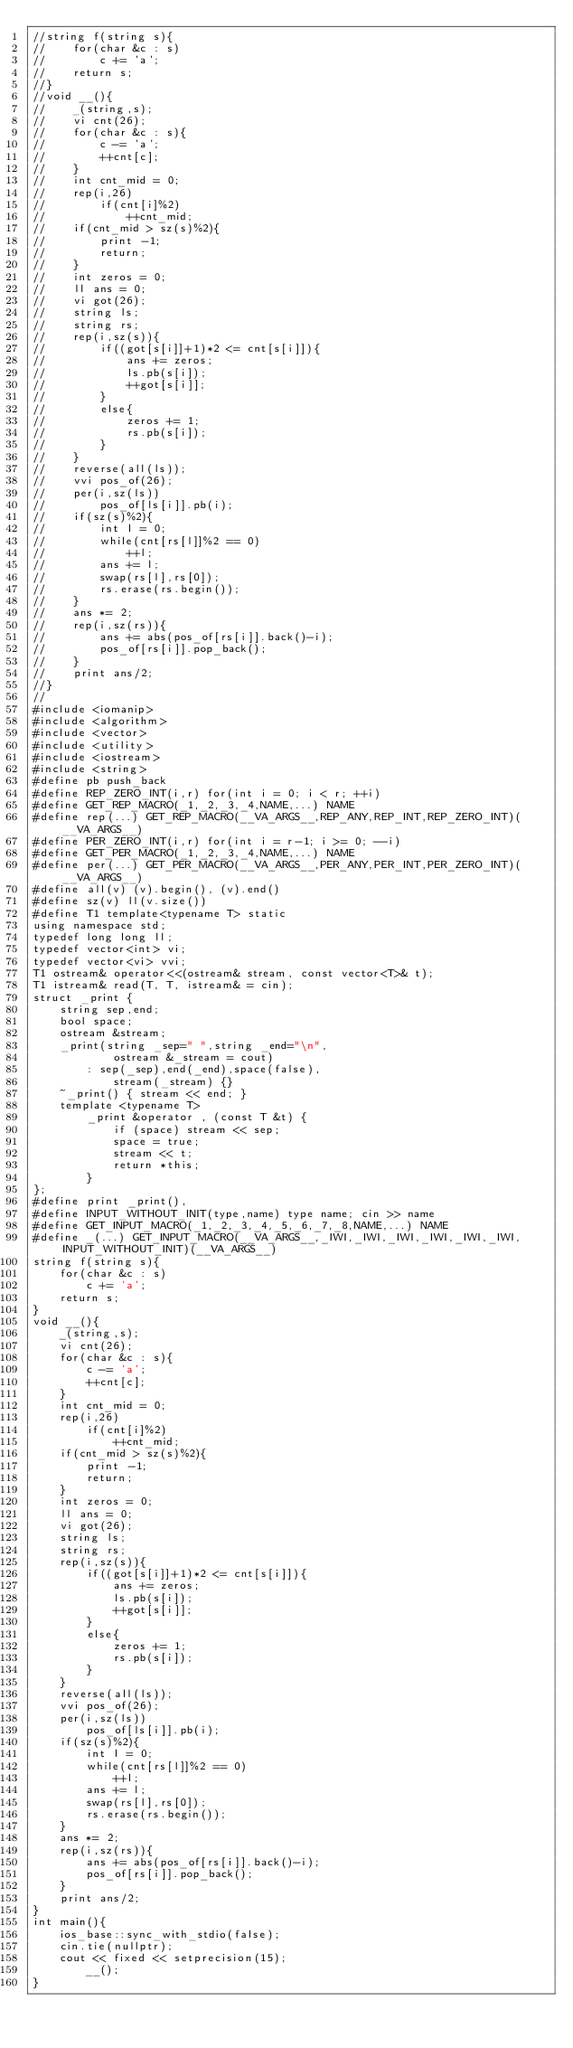<code> <loc_0><loc_0><loc_500><loc_500><_C++_>//string f(string s){
//    for(char &c : s)
//        c += 'a';
//    return s;
//}
//void __(){
//    _(string,s);
//    vi cnt(26);
//    for(char &c : s){
//        c -= 'a';
//        ++cnt[c];
//    }
//    int cnt_mid = 0;
//    rep(i,26)
//        if(cnt[i]%2)
//            ++cnt_mid;
//    if(cnt_mid > sz(s)%2){
//        print -1;
//        return;
//    }
//    int zeros = 0;
//    ll ans = 0;
//    vi got(26);
//    string ls;
//    string rs;
//    rep(i,sz(s)){
//        if((got[s[i]]+1)*2 <= cnt[s[i]]){
//            ans += zeros;
//            ls.pb(s[i]);
//            ++got[s[i]];
//        }
//        else{
//            zeros += 1;
//            rs.pb(s[i]);
//        }
//    }
//    reverse(all(ls));
//    vvi pos_of(26);
//    per(i,sz(ls))
//        pos_of[ls[i]].pb(i);
//    if(sz(s)%2){
//        int l = 0;
//        while(cnt[rs[l]]%2 == 0)
//            ++l;
//        ans += l;
//        swap(rs[l],rs[0]);
//        rs.erase(rs.begin());
//    }
//    ans *= 2;
//    rep(i,sz(rs)){
//        ans += abs(pos_of[rs[i]].back()-i);
//        pos_of[rs[i]].pop_back();
//    }
//    print ans/2;
//}
//
#include <iomanip>
#include <algorithm>
#include <vector>
#include <utility>
#include <iostream>
#include <string>
#define pb push_back
#define REP_ZERO_INT(i,r) for(int i = 0; i < r; ++i)
#define GET_REP_MACRO(_1,_2,_3,_4,NAME,...) NAME
#define rep(...) GET_REP_MACRO(__VA_ARGS__,REP_ANY,REP_INT,REP_ZERO_INT)(__VA_ARGS__)
#define PER_ZERO_INT(i,r) for(int i = r-1; i >= 0; --i)
#define GET_PER_MACRO(_1,_2,_3,_4,NAME,...) NAME
#define per(...) GET_PER_MACRO(__VA_ARGS__,PER_ANY,PER_INT,PER_ZERO_INT)(__VA_ARGS__)
#define all(v) (v).begin(), (v).end()
#define sz(v) ll(v.size())
#define T1 template<typename T> static
using namespace std;
typedef long long ll;
typedef vector<int> vi;
typedef vector<vi> vvi;
T1 ostream& operator<<(ostream& stream, const vector<T>& t);
T1 istream& read(T, T, istream& = cin);
struct _print {
    string sep,end;
    bool space;
    ostream &stream;
    _print(string _sep=" ",string _end="\n",
            ostream &_stream = cout)
        : sep(_sep),end(_end),space(false),
            stream(_stream) {}
    ~_print() { stream << end; }
    template <typename T>
        _print &operator , (const T &t) {
            if (space) stream << sep;
            space = true;
            stream << t;
            return *this;
        }
};
#define print _print(),
#define INPUT_WITHOUT_INIT(type,name) type name; cin >> name
#define GET_INPUT_MACRO(_1,_2,_3,_4,_5,_6,_7,_8,NAME,...) NAME
#define _(...) GET_INPUT_MACRO(__VA_ARGS__,_IWI,_IWI,_IWI,_IWI,_IWI,_IWI,INPUT_WITHOUT_INIT)(__VA_ARGS__)
string f(string s){
    for(char &c : s)
        c += 'a';
    return s;
}
void __(){
    _(string,s);
    vi cnt(26);
    for(char &c : s){
        c -= 'a';
        ++cnt[c];
    }
    int cnt_mid = 0;
    rep(i,26)
        if(cnt[i]%2)
            ++cnt_mid;
    if(cnt_mid > sz(s)%2){
        print -1;
        return;
    }
    int zeros = 0;
    ll ans = 0;
    vi got(26);
    string ls;
    string rs;
    rep(i,sz(s)){
        if((got[s[i]]+1)*2 <= cnt[s[i]]){
            ans += zeros;
            ls.pb(s[i]);
            ++got[s[i]];
        }
        else{
            zeros += 1;
            rs.pb(s[i]);
        }
    }
    reverse(all(ls));
    vvi pos_of(26);
    per(i,sz(ls))
        pos_of[ls[i]].pb(i);
    if(sz(s)%2){
        int l = 0;
        while(cnt[rs[l]]%2 == 0)
            ++l;
        ans += l;
        swap(rs[l],rs[0]);
        rs.erase(rs.begin());
    }
    ans *= 2;
    rep(i,sz(rs)){
        ans += abs(pos_of[rs[i]].back()-i);
        pos_of[rs[i]].pop_back();
    }
    print ans/2;
}
int main(){
    ios_base::sync_with_stdio(false);
    cin.tie(nullptr);
    cout << fixed << setprecision(15);
        __();
}
</code> 